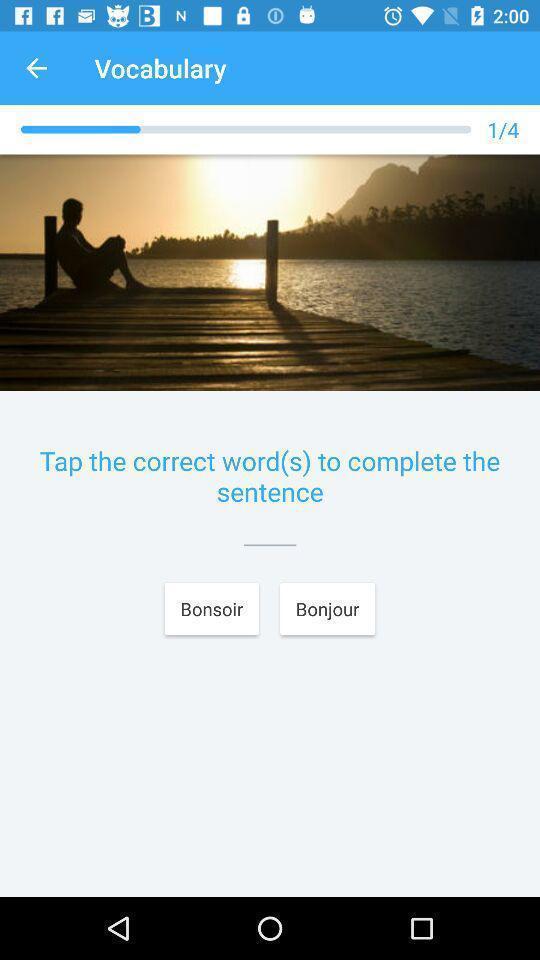Describe the visual elements of this screenshot. Screen shows vocabulary page in language learning app. 